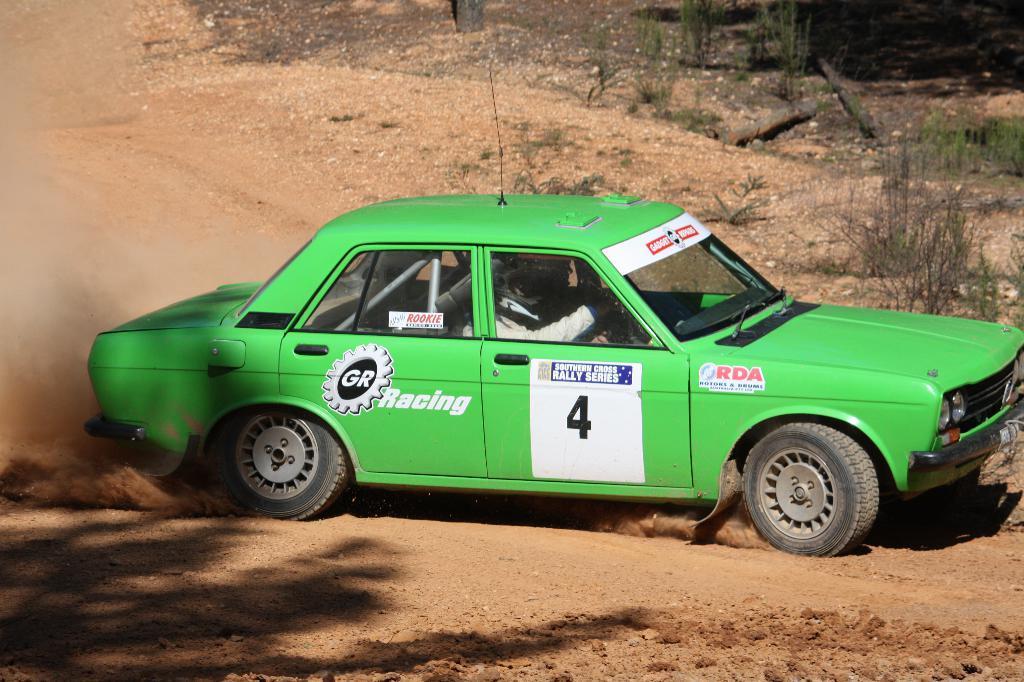In one or two sentences, can you explain what this image depicts? This picture is clicked outside. In the center we can see a person seems to be driving a green color car and we can see the text and number on the car. In the background we can see the plants and the mud and some other items. 